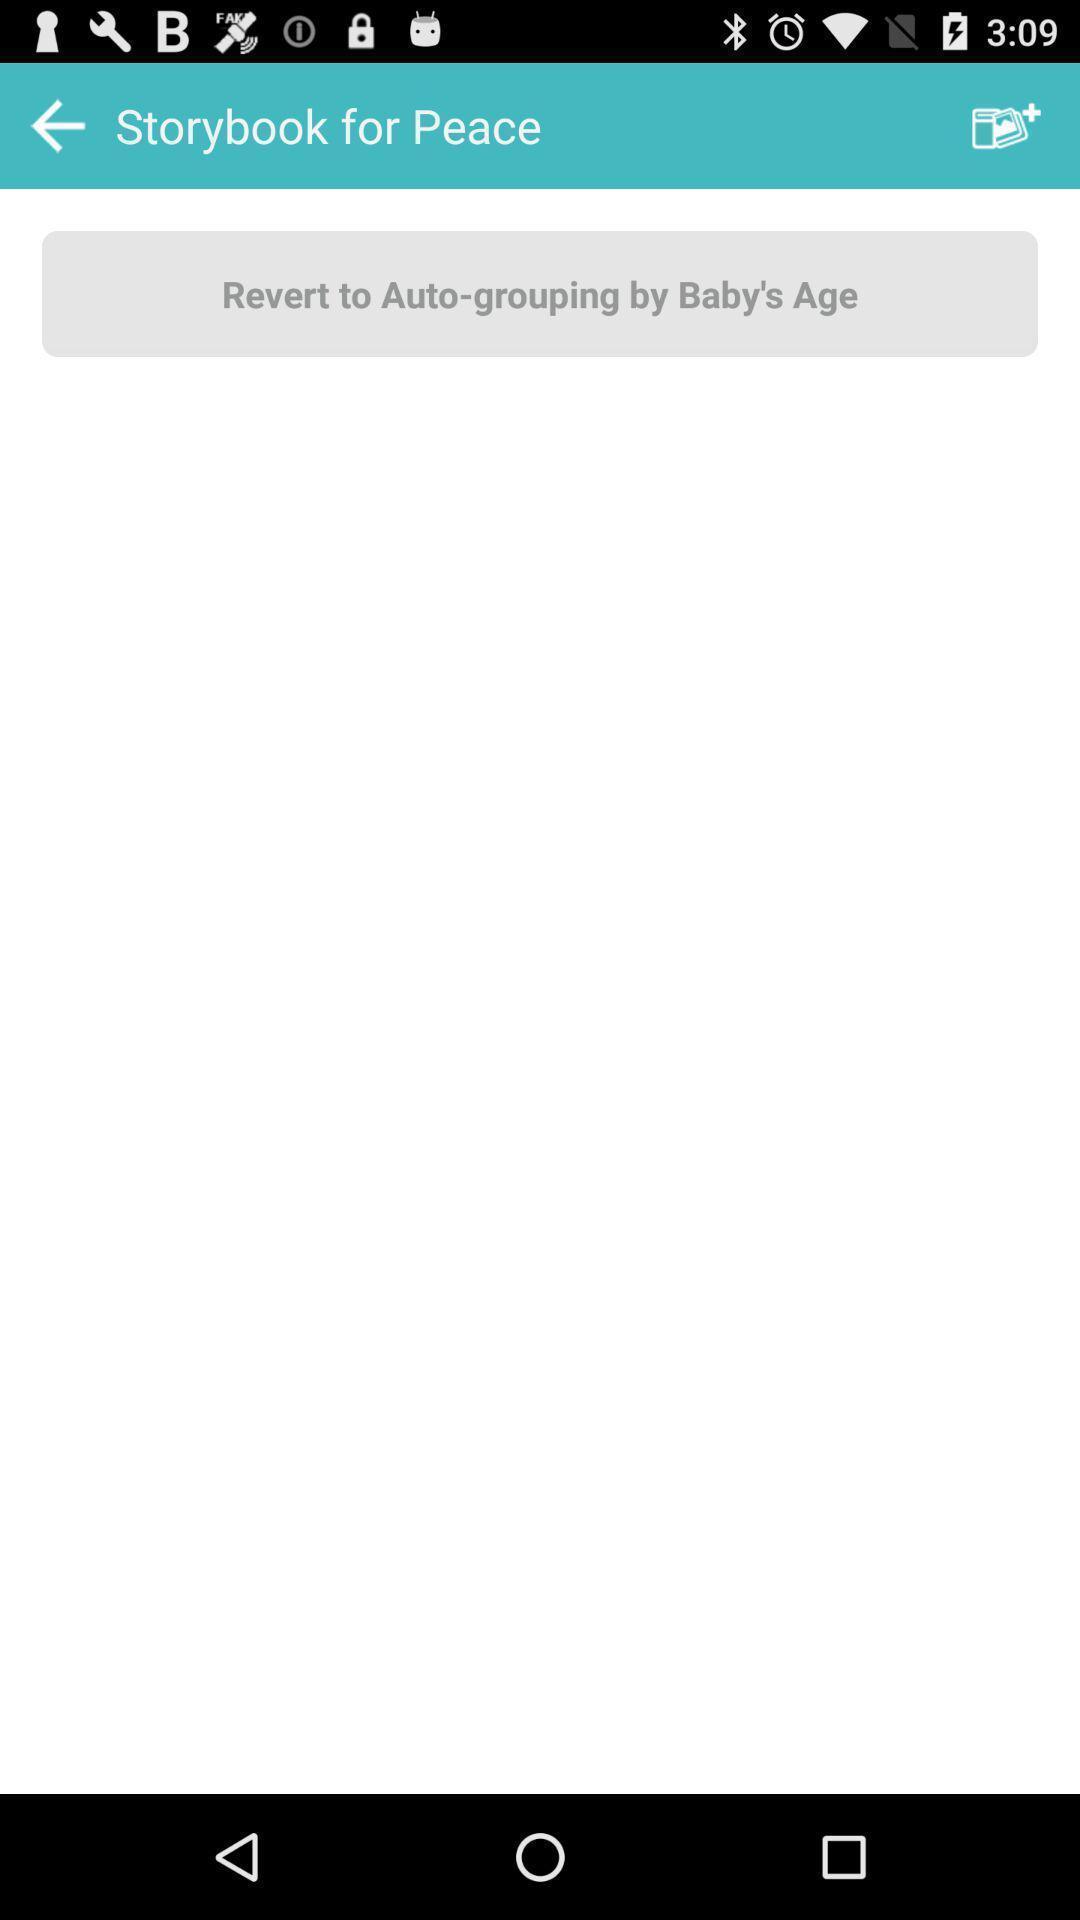Describe the key features of this screenshot. Screen displaying a blank page in story book page. 